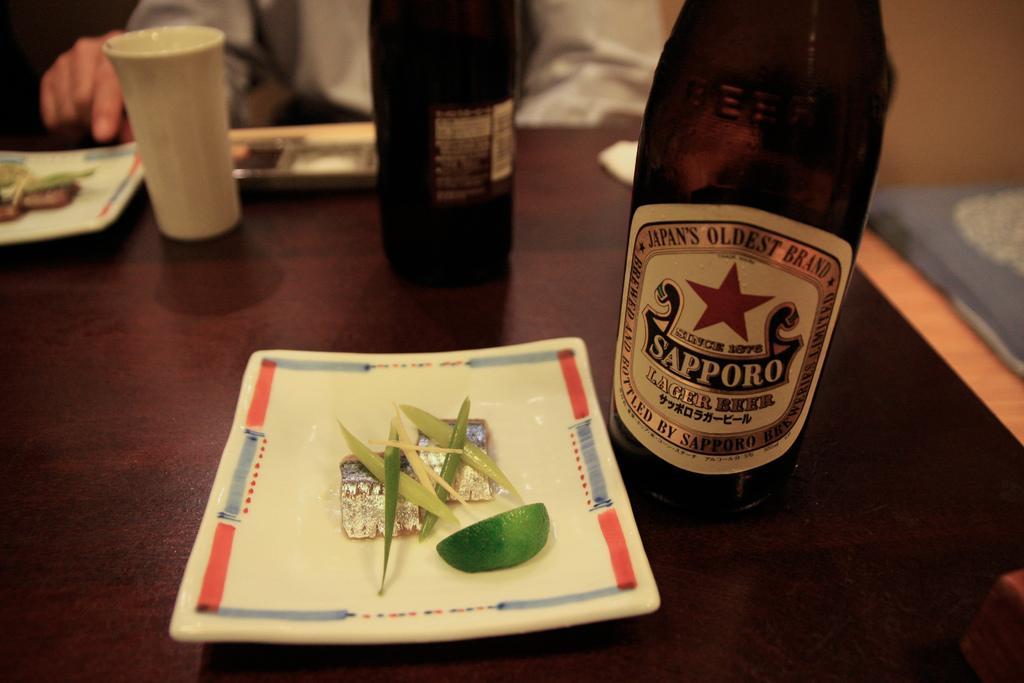Can you describe this image briefly? There are bottles, a glass, some objects on a plate and other objects on a wooden table. In the background, there is a person sitting. 